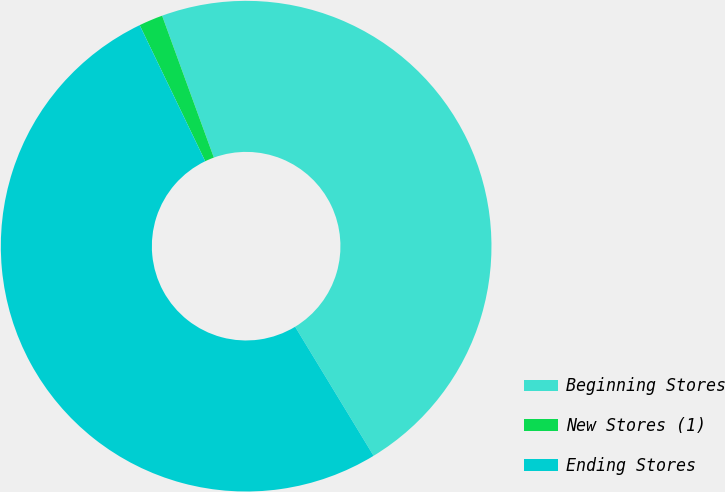Convert chart to OTSL. <chart><loc_0><loc_0><loc_500><loc_500><pie_chart><fcel>Beginning Stores<fcel>New Stores (1)<fcel>Ending Stores<nl><fcel>46.87%<fcel>1.58%<fcel>51.55%<nl></chart> 